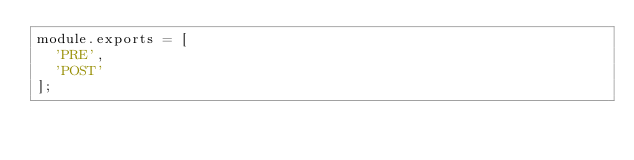<code> <loc_0><loc_0><loc_500><loc_500><_JavaScript_>module.exports = [
  'PRE',
  'POST'
];
</code> 